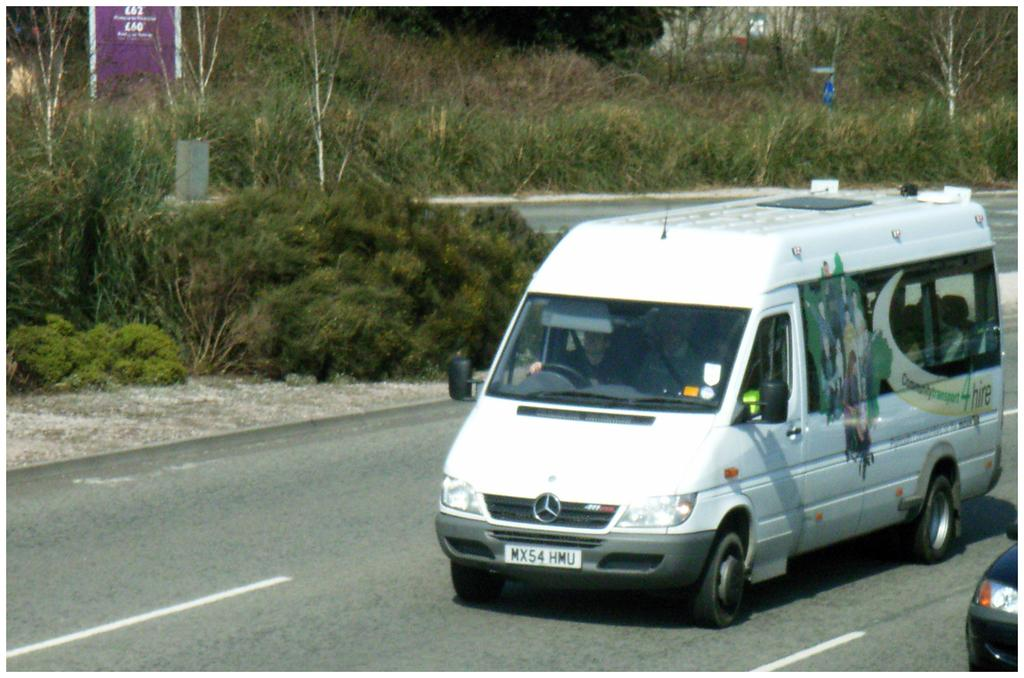What can be seen in the foreground of the image? There are vehicles on the road in the foreground. What is visible in the background of the image? There are plants, trees, a board, and a house in the background. Can you describe the natural elements in the image? There are plants and trees in the background. When was the image taken? The image was taken during the day. What type of underwear is hanging on the trees in the image? There is no underwear present in the image; it features vehicles on the road and natural elements in the background. Can you see the moon in the image? The image was taken during the day, so the moon is not visible. 